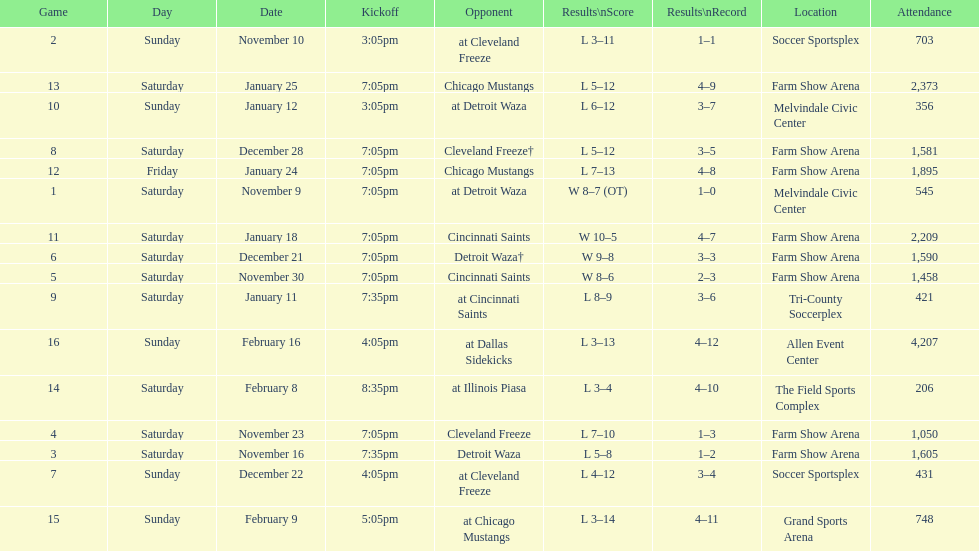What was the location before tri-county soccerplex? Farm Show Arena. 